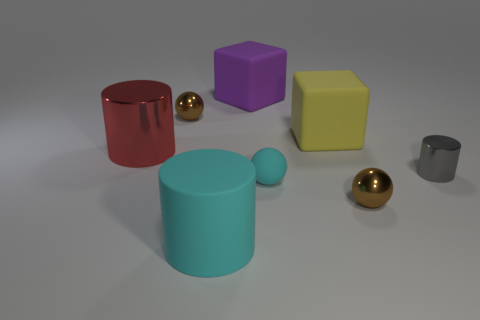How many brown spheres must be subtracted to get 1 brown spheres? 1 Subtract all big cyan cylinders. How many cylinders are left? 2 Subtract all purple cylinders. How many brown balls are left? 2 Add 1 gray shiny things. How many objects exist? 9 Subtract all purple balls. Subtract all blue cylinders. How many balls are left? 3 Subtract all balls. How many objects are left? 5 Subtract 1 red cylinders. How many objects are left? 7 Subtract all tiny gray things. Subtract all matte balls. How many objects are left? 6 Add 7 large cylinders. How many large cylinders are left? 9 Add 5 brown metal things. How many brown metal things exist? 7 